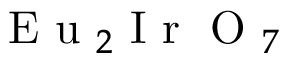Convert formula to latex. <formula><loc_0><loc_0><loc_500><loc_500>E u _ { 2 } I r O _ { 7 }</formula> 